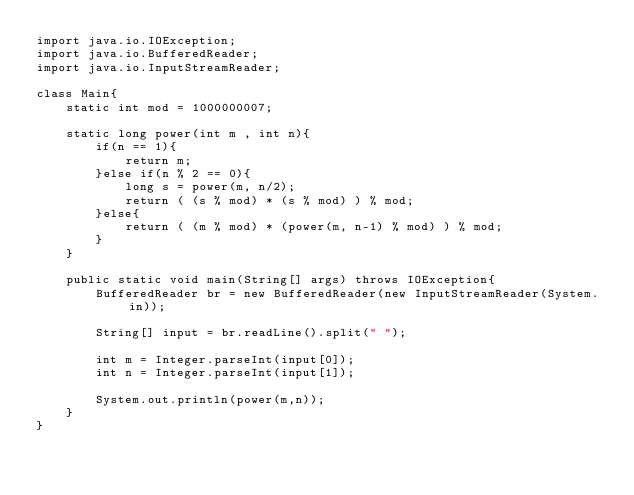Convert code to text. <code><loc_0><loc_0><loc_500><loc_500><_Java_>import java.io.IOException;
import java.io.BufferedReader;
import java.io.InputStreamReader;

class Main{
    static int mod = 1000000007;

    static long power(int m , int n){
        if(n == 1){
            return m;
        }else if(n % 2 == 0){
            long s = power(m, n/2);
            return ( (s % mod) * (s % mod) ) % mod;
        }else{
            return ( (m % mod) * (power(m, n-1) % mod) ) % mod;
        }
    }

    public static void main(String[] args) throws IOException{
        BufferedReader br = new BufferedReader(new InputStreamReader(System.in));

        String[] input = br.readLine().split(" ");

        int m = Integer.parseInt(input[0]);
        int n = Integer.parseInt(input[1]);

        System.out.println(power(m,n));
    }
}
</code> 